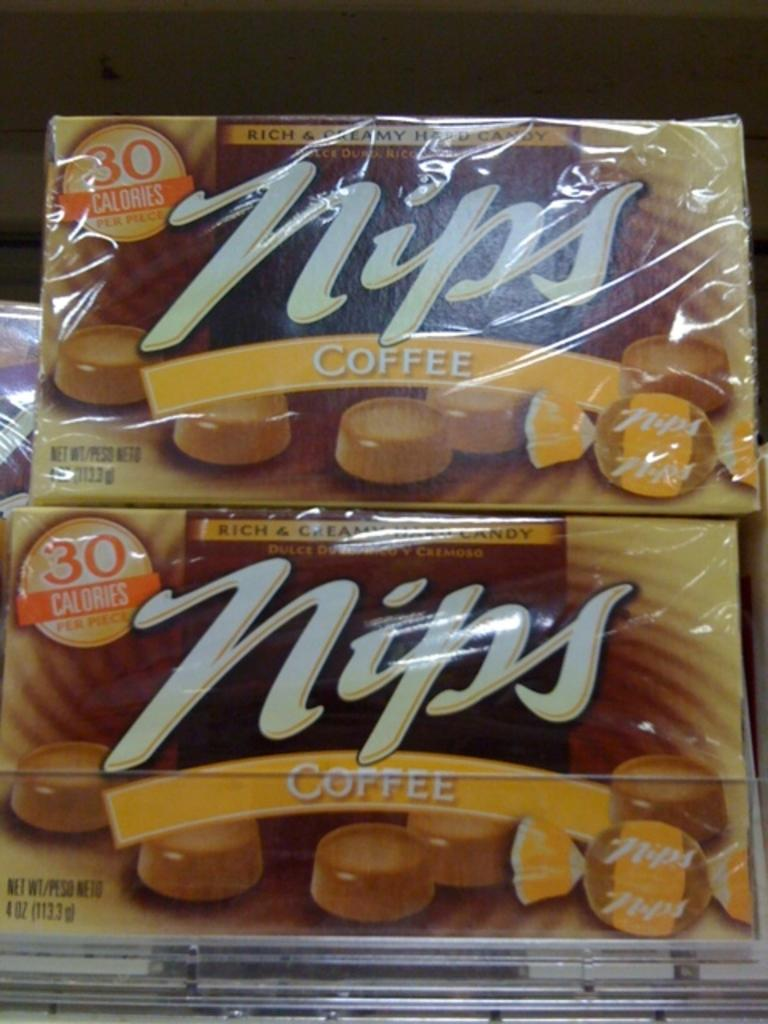What items are present in the image? There are two coffee bar chocolate packs in the image. Where are the chocolate packs located? The chocolate packs are on a shelf. What type of loaf can be seen in the image? There is no loaf present in the image; it only features two coffee bar chocolate packs. Is there a market visible in the image? No, there is no market visible in the image. 